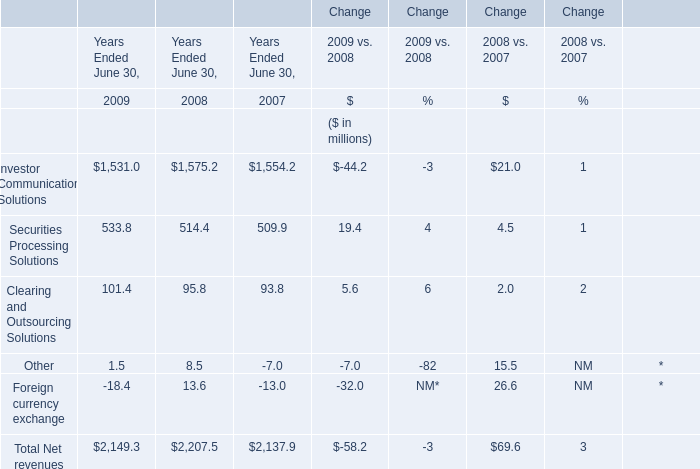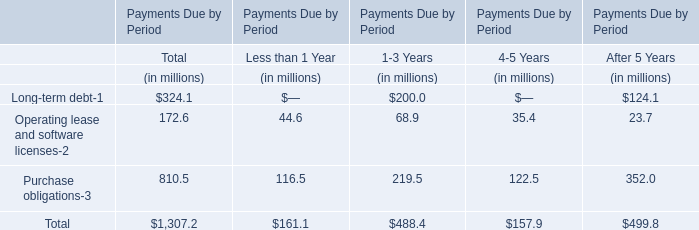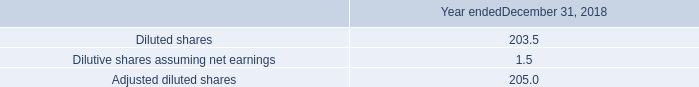What's the total amount of the Total Net revenues in the years where Foreign currency exchange is greater than 0? (in million) 
Answer: 2207.5. 